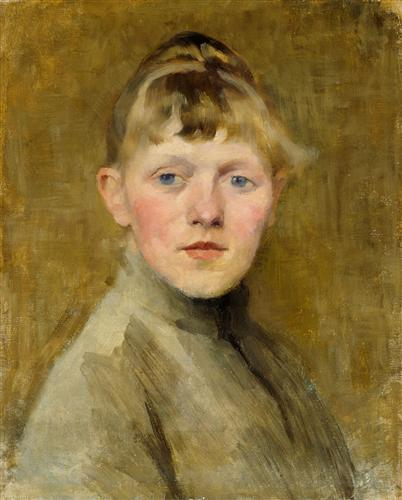What might be the historical and social context surrounding the boy in this painting? This portrait, painted in the impressionist style, suggests it was created in the late 19th century, a period marked by significant social changes and a flourishing of the arts. The boy's simple yet tidy attire could indicate a middle-class background, typical of the time when increasing numbers of the European population were able to afford modest luxuries and education for children. The painting might be exploring themes of childhood in the context of these changing societal norms, reflecting on the increasing value placed on youth and individuality during the era. 